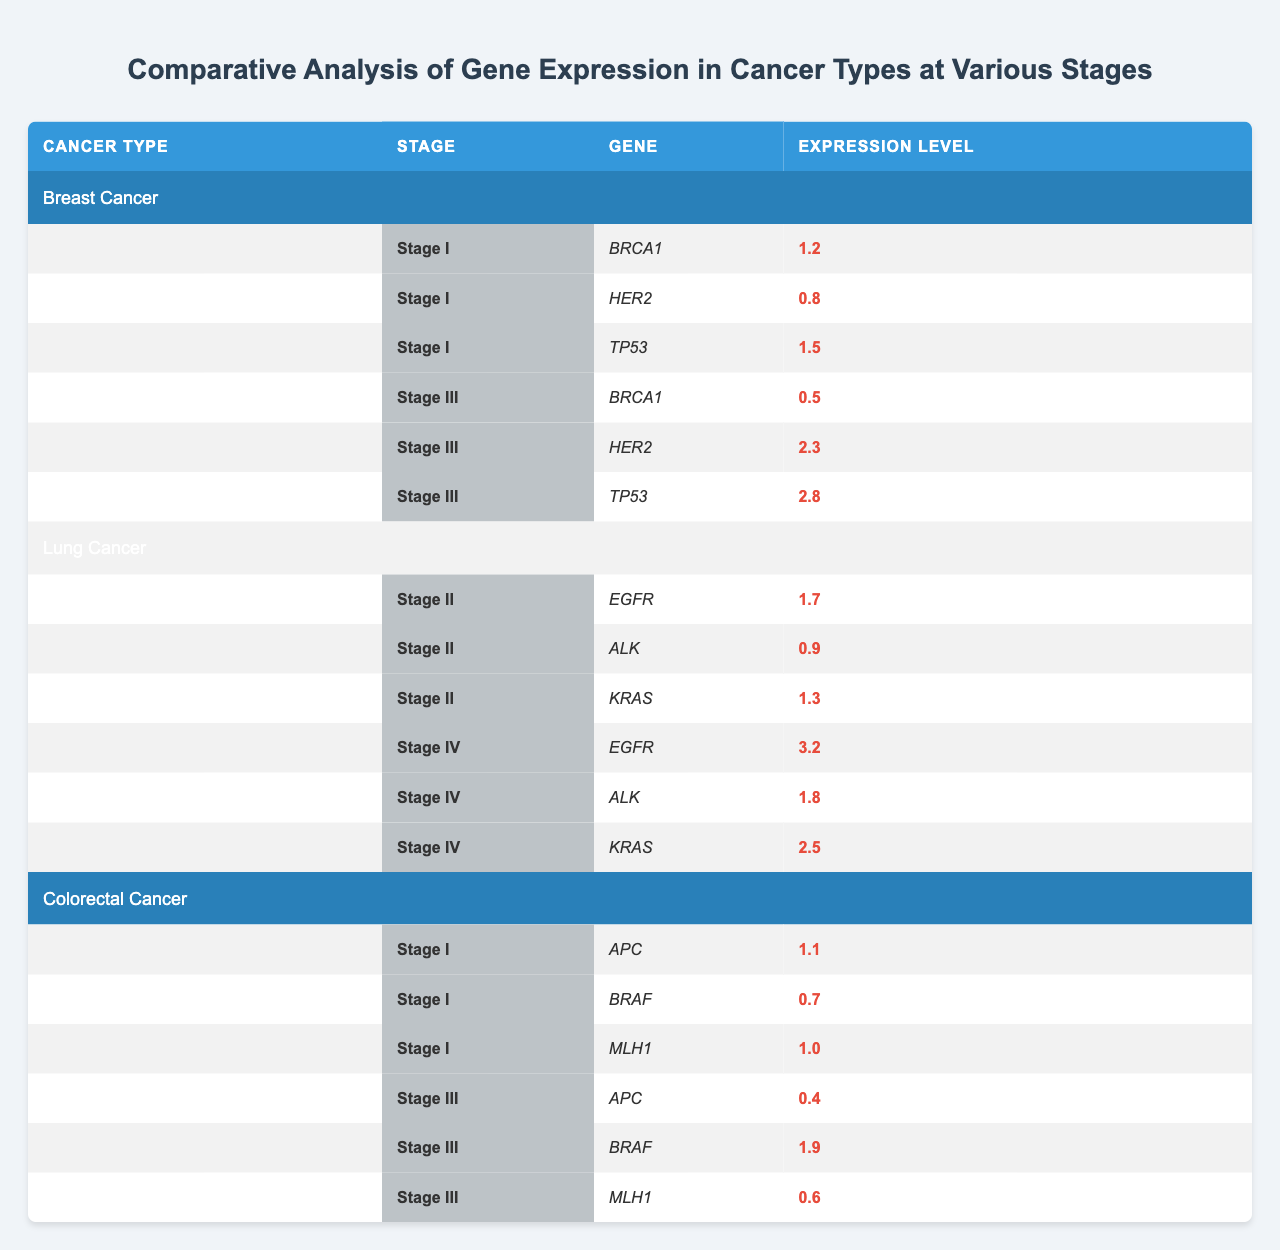What is the expression level of BRCA1 in Stage I of Breast Cancer? The table shows that in Stage I of Breast Cancer, the expression level of BRCA1 is 1.2.
Answer: 1.2 What is the highest expression level recorded among all genes in Stage IV of Lung Cancer? In Stage IV of Lung Cancer, EGFR has the highest expression level of 3.2, compared to ALK (1.8) and KRAS (2.5).
Answer: 3.2 Is the expression level of TP53 higher in Stage III of Breast Cancer compared to Stage I? In Stage III, the expression level of TP53 is 2.8 which is higher than the 1.5 in Stage I, so the statement is true.
Answer: Yes Which gene shows the biggest decrease in expression level from Stage I to Stage III in Colorectal Cancer? The expression level of APC decreases from 1.1 in Stage I to 0.4 in Stage III, which is a change of -0.7. The other genes (BRAF and MLH1) do not show a decrease as significant.
Answer: APC What is the average expression level of genes in Stage II of Lung Cancer? The expression levels for Stage II are EGFR (1.7), ALK (0.9), and KRAS (1.3). Their sum is 1.7 + 0.9 + 1.3 = 3.9; thus, the average is 3.9 / 3 = 1.3.
Answer: 1.3 Does the expression level of HER2 increase in Stage III of Breast Cancer compared to Stage I? HER2 in Stage I is 0.8, and in Stage III it is 2.3, indicating an increase. Therefore, the statement is true.
Answer: Yes Which stage has the highest overall expression level between the two stages of Colorectal Cancer? In Stage I, the total expression level is 1.1 + 0.7 + 1.0 = 2.8, and in Stage III it is 0.4 + 1.9 + 0.6 = 3.0. Thus, Stage III is higher overall.
Answer: Stage III What is the expression level of KRAS in Stage IV of Lung Cancer, and how does it compare to Stage II? In Stage IV, KRAS has an expression level of 2.5, while in Stage II it is 1.3. Therefore, KRAS has a higher expression level in Stage IV than in Stage II.
Answer: 2.5 Which gene in Colorectal Cancer has the lowest expression level in Stage III? The lowest expression level in Stage III is for APC, with a level of 0.4 compared to BRAF (1.9) and MLH1 (0.6).
Answer: APC What is the total expression level of all genes in Stage III of Breast Cancer? Stage III totals are: BRCA1 (0.5) + HER2 (2.3) + TP53 (2.8) = 5.6.
Answer: 5.6 